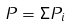<formula> <loc_0><loc_0><loc_500><loc_500>P = \Sigma P _ { i }</formula> 